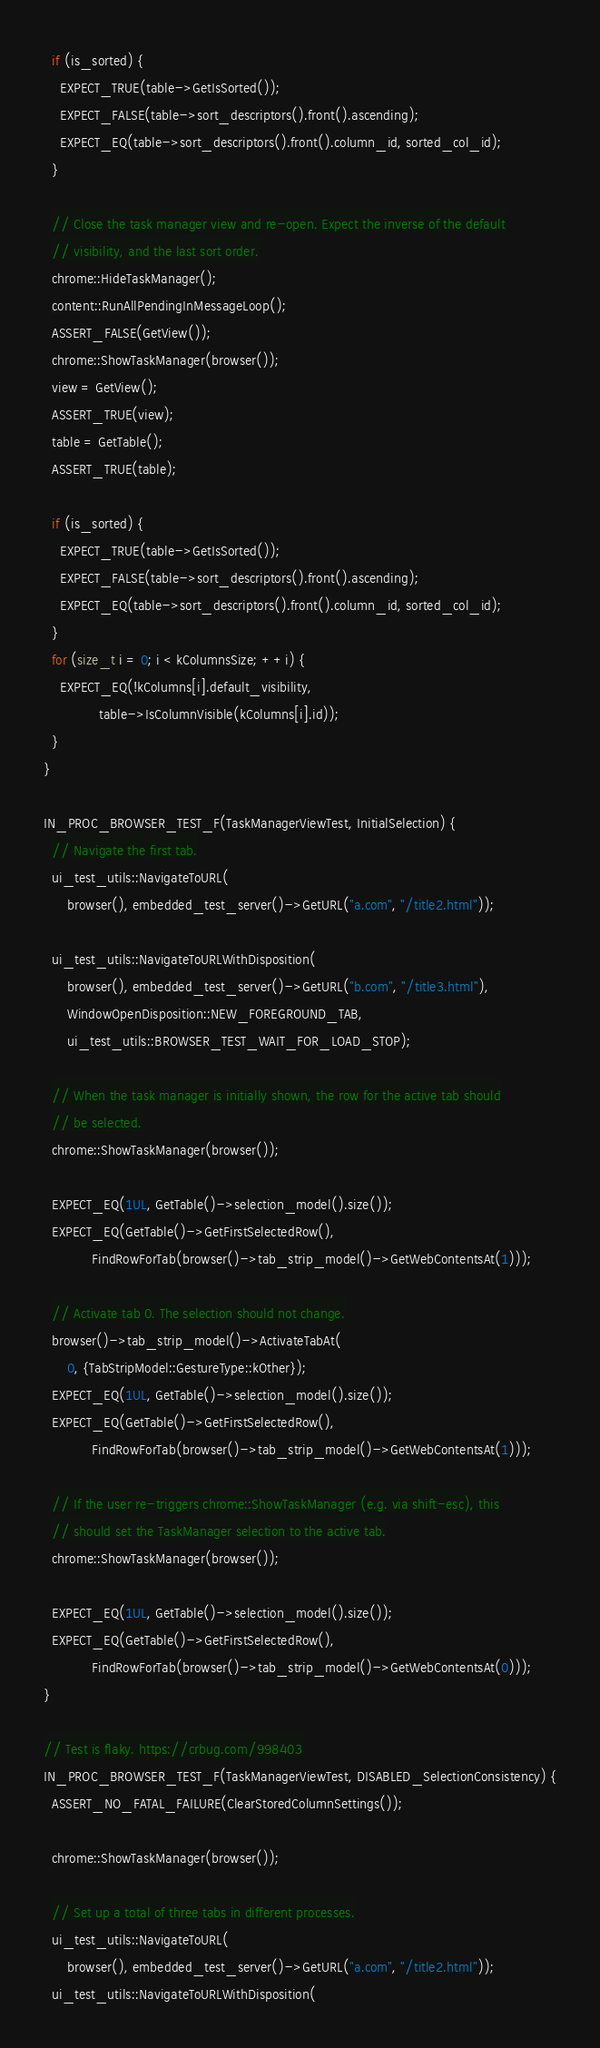Convert code to text. <code><loc_0><loc_0><loc_500><loc_500><_C++_>
  if (is_sorted) {
    EXPECT_TRUE(table->GetIsSorted());
    EXPECT_FALSE(table->sort_descriptors().front().ascending);
    EXPECT_EQ(table->sort_descriptors().front().column_id, sorted_col_id);
  }

  // Close the task manager view and re-open. Expect the inverse of the default
  // visibility, and the last sort order.
  chrome::HideTaskManager();
  content::RunAllPendingInMessageLoop();
  ASSERT_FALSE(GetView());
  chrome::ShowTaskManager(browser());
  view = GetView();
  ASSERT_TRUE(view);
  table = GetTable();
  ASSERT_TRUE(table);

  if (is_sorted) {
    EXPECT_TRUE(table->GetIsSorted());
    EXPECT_FALSE(table->sort_descriptors().front().ascending);
    EXPECT_EQ(table->sort_descriptors().front().column_id, sorted_col_id);
  }
  for (size_t i = 0; i < kColumnsSize; ++i) {
    EXPECT_EQ(!kColumns[i].default_visibility,
              table->IsColumnVisible(kColumns[i].id));
  }
}

IN_PROC_BROWSER_TEST_F(TaskManagerViewTest, InitialSelection) {
  // Navigate the first tab.
  ui_test_utils::NavigateToURL(
      browser(), embedded_test_server()->GetURL("a.com", "/title2.html"));

  ui_test_utils::NavigateToURLWithDisposition(
      browser(), embedded_test_server()->GetURL("b.com", "/title3.html"),
      WindowOpenDisposition::NEW_FOREGROUND_TAB,
      ui_test_utils::BROWSER_TEST_WAIT_FOR_LOAD_STOP);

  // When the task manager is initially shown, the row for the active tab should
  // be selected.
  chrome::ShowTaskManager(browser());

  EXPECT_EQ(1UL, GetTable()->selection_model().size());
  EXPECT_EQ(GetTable()->GetFirstSelectedRow(),
            FindRowForTab(browser()->tab_strip_model()->GetWebContentsAt(1)));

  // Activate tab 0. The selection should not change.
  browser()->tab_strip_model()->ActivateTabAt(
      0, {TabStripModel::GestureType::kOther});
  EXPECT_EQ(1UL, GetTable()->selection_model().size());
  EXPECT_EQ(GetTable()->GetFirstSelectedRow(),
            FindRowForTab(browser()->tab_strip_model()->GetWebContentsAt(1)));

  // If the user re-triggers chrome::ShowTaskManager (e.g. via shift-esc), this
  // should set the TaskManager selection to the active tab.
  chrome::ShowTaskManager(browser());

  EXPECT_EQ(1UL, GetTable()->selection_model().size());
  EXPECT_EQ(GetTable()->GetFirstSelectedRow(),
            FindRowForTab(browser()->tab_strip_model()->GetWebContentsAt(0)));
}

// Test is flaky. https://crbug.com/998403
IN_PROC_BROWSER_TEST_F(TaskManagerViewTest, DISABLED_SelectionConsistency) {
  ASSERT_NO_FATAL_FAILURE(ClearStoredColumnSettings());

  chrome::ShowTaskManager(browser());

  // Set up a total of three tabs in different processes.
  ui_test_utils::NavigateToURL(
      browser(), embedded_test_server()->GetURL("a.com", "/title2.html"));
  ui_test_utils::NavigateToURLWithDisposition(</code> 